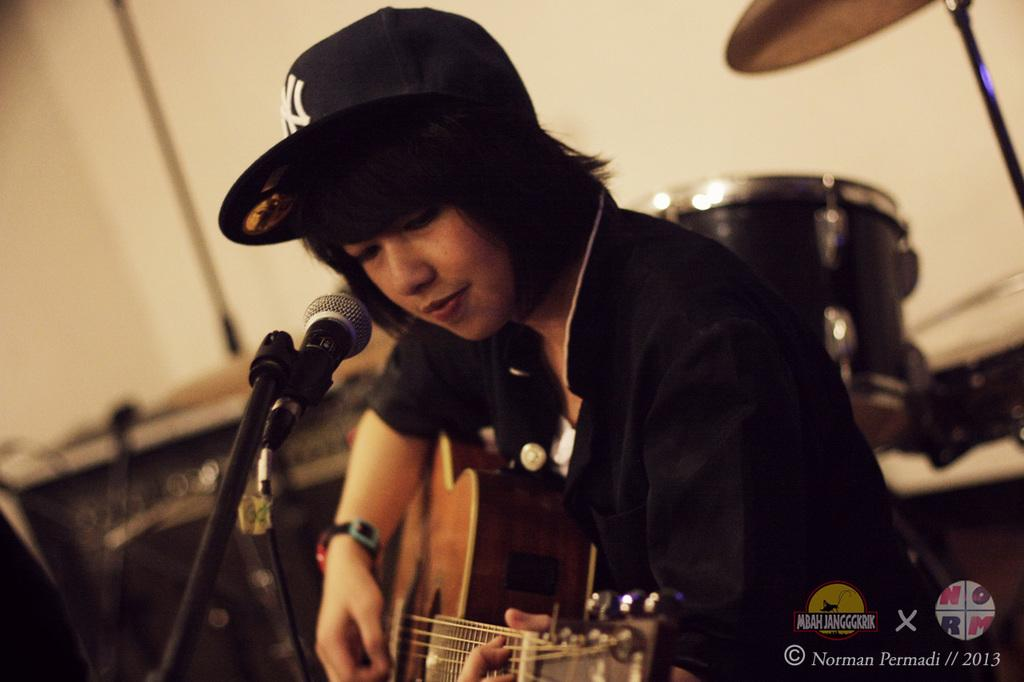Who is the main subject in the image? There is a woman in the image. What is the woman doing in the image? The woman is seated on a chair and playing a guitar. What object is in front of the woman? There is a microphone in front of the woman. What type of collar can be seen on the brick in the image? There is no brick present in the image, and therefore no collar can be seen on it. 